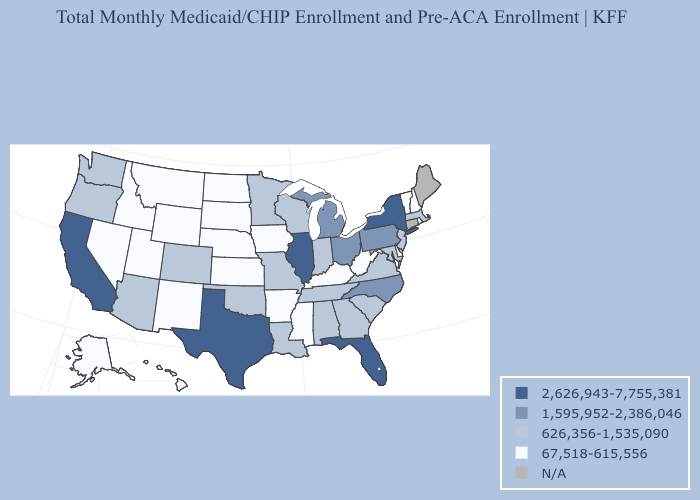Name the states that have a value in the range 67,518-615,556?
Answer briefly. Alaska, Arkansas, Delaware, Hawaii, Idaho, Iowa, Kansas, Kentucky, Mississippi, Montana, Nebraska, Nevada, New Hampshire, New Mexico, North Dakota, Rhode Island, South Dakota, Utah, Vermont, West Virginia, Wyoming. Does Rhode Island have the lowest value in the Northeast?
Keep it brief. Yes. Among the states that border Michigan , does Indiana have the lowest value?
Concise answer only. Yes. Among the states that border Mississippi , does Arkansas have the lowest value?
Write a very short answer. Yes. Name the states that have a value in the range 67,518-615,556?
Short answer required. Alaska, Arkansas, Delaware, Hawaii, Idaho, Iowa, Kansas, Kentucky, Mississippi, Montana, Nebraska, Nevada, New Hampshire, New Mexico, North Dakota, Rhode Island, South Dakota, Utah, Vermont, West Virginia, Wyoming. Does New Mexico have the lowest value in the USA?
Keep it brief. Yes. What is the value of Alaska?
Quick response, please. 67,518-615,556. Which states have the highest value in the USA?
Quick response, please. California, Florida, Illinois, New York, Texas. Does Massachusetts have the lowest value in the Northeast?
Answer briefly. No. Name the states that have a value in the range N/A?
Concise answer only. Connecticut, Maine. What is the value of Arizona?
Answer briefly. 626,356-1,535,090. What is the value of Texas?
Answer briefly. 2,626,943-7,755,381. Does Ohio have the lowest value in the MidWest?
Keep it brief. No. Among the states that border Kentucky , which have the highest value?
Be succinct. Illinois. Which states have the lowest value in the South?
Be succinct. Arkansas, Delaware, Kentucky, Mississippi, West Virginia. 